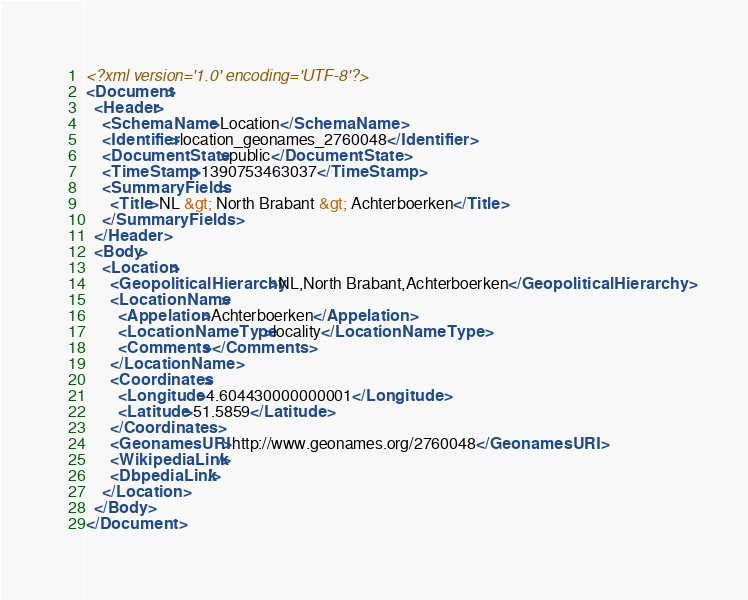<code> <loc_0><loc_0><loc_500><loc_500><_XML_><?xml version='1.0' encoding='UTF-8'?>
<Document>
  <Header>
    <SchemaName>Location</SchemaName>
    <Identifier>location_geonames_2760048</Identifier>
    <DocumentState>public</DocumentState>
    <TimeStamp>1390753463037</TimeStamp>
    <SummaryFields>
      <Title>NL &gt; North Brabant &gt; Achterboerken</Title>
    </SummaryFields>
  </Header>
  <Body>
    <Location>
      <GeopoliticalHierarchy>NL,North Brabant,Achterboerken</GeopoliticalHierarchy>
      <LocationName>
        <Appelation>Achterboerken</Appelation>
        <LocationNameType>locality</LocationNameType>
        <Comments></Comments>
      </LocationName>
      <Coordinates>
        <Longitude>4.604430000000001</Longitude>
        <Latitude>51.5859</Latitude>
      </Coordinates>
      <GeonamesURI>http://www.geonames.org/2760048</GeonamesURI>
      <WikipediaLink/>
      <DbpediaLink/>
    </Location>
  </Body>
</Document>
</code> 